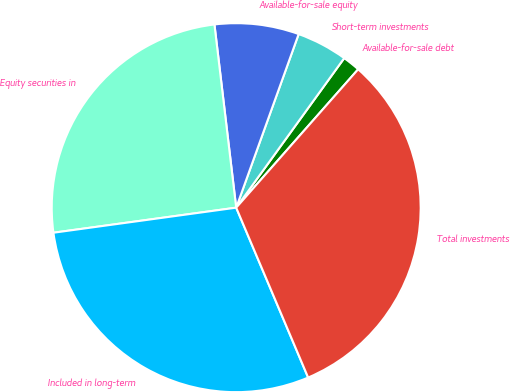Convert chart. <chart><loc_0><loc_0><loc_500><loc_500><pie_chart><fcel>Available-for-sale debt<fcel>Short-term investments<fcel>Available-for-sale equity<fcel>Equity securities in<fcel>Included in long-term<fcel>Total investments<nl><fcel>1.54%<fcel>4.46%<fcel>7.38%<fcel>25.29%<fcel>29.21%<fcel>32.13%<nl></chart> 